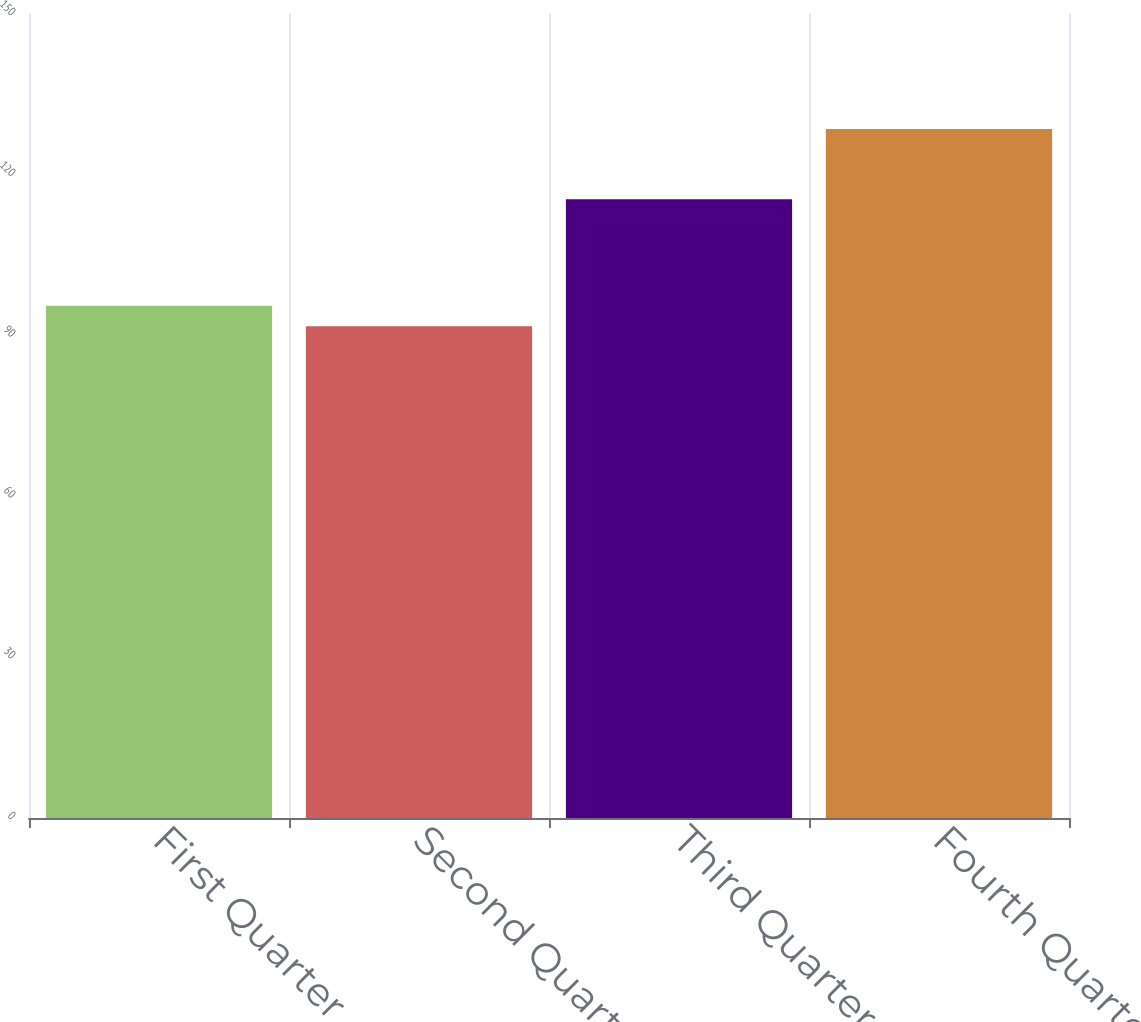<chart> <loc_0><loc_0><loc_500><loc_500><bar_chart><fcel>First Quarter<fcel>Second Quarter<fcel>Third Quarter<fcel>Fourth Quarter<nl><fcel>95.59<fcel>91.76<fcel>115.45<fcel>128.56<nl></chart> 